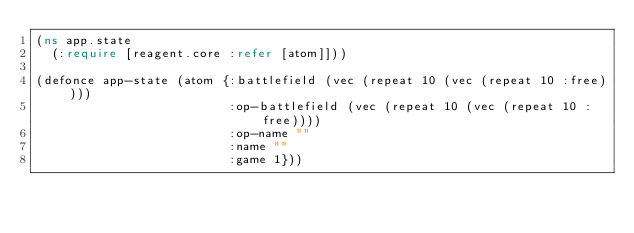Convert code to text. <code><loc_0><loc_0><loc_500><loc_500><_Clojure_>(ns app.state
  (:require [reagent.core :refer [atom]]))

(defonce app-state (atom {:battlefield (vec (repeat 10 (vec (repeat 10 :free))))
                          :op-battlefield (vec (repeat 10 (vec (repeat 10 :free))))
                          :op-name ""
                          :name ""
                          :game 1}))
</code> 